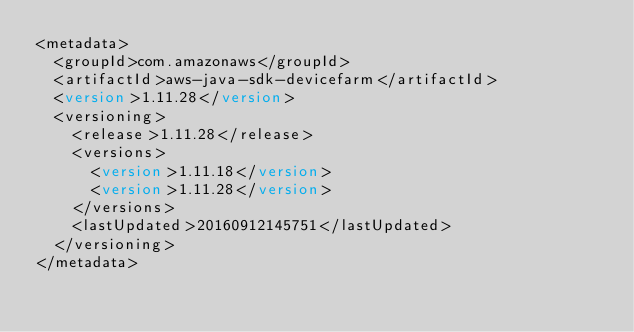Convert code to text. <code><loc_0><loc_0><loc_500><loc_500><_XML_><metadata>
	<groupId>com.amazonaws</groupId>
	<artifactId>aws-java-sdk-devicefarm</artifactId>
	<version>1.11.28</version>
	<versioning>
		<release>1.11.28</release>
		<versions>
 			<version>1.11.18</version>
			<version>1.11.28</version>
		</versions>
		<lastUpdated>20160912145751</lastUpdated>
	</versioning>
</metadata></code> 